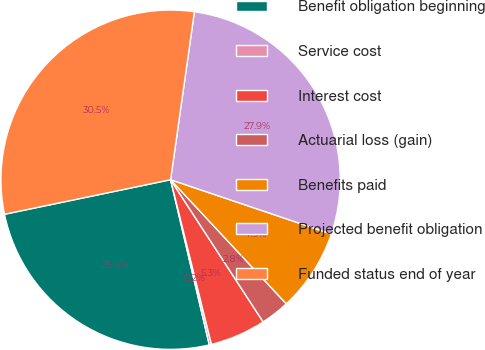<chart> <loc_0><loc_0><loc_500><loc_500><pie_chart><fcel>Benefit obligation beginning<fcel>Service cost<fcel>Interest cost<fcel>Actuarial loss (gain)<fcel>Benefits paid<fcel>Projected benefit obligation<fcel>Funded status end of year<nl><fcel>25.4%<fcel>0.21%<fcel>5.31%<fcel>2.76%<fcel>7.87%<fcel>27.95%<fcel>30.51%<nl></chart> 